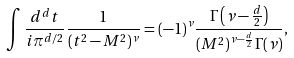<formula> <loc_0><loc_0><loc_500><loc_500>\int \frac { d ^ { d } t } { i \pi ^ { d / 2 } } \frac { 1 } { ( t ^ { 2 } - M ^ { 2 } ) ^ { \nu } } = ( - 1 ) ^ { \nu } \frac { \Gamma \left ( \nu - \frac { d } { 2 } \right ) } { ( M ^ { 2 } ) ^ { \nu - \frac { d } { 2 } } \Gamma ( \nu ) } ,</formula> 